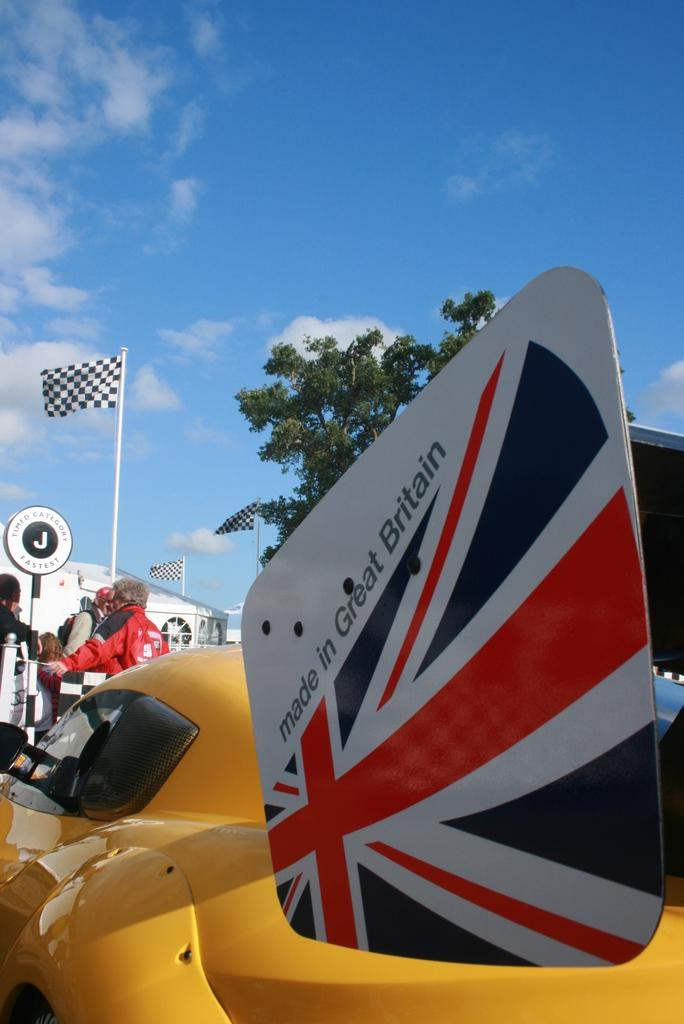<image>
Write a terse but informative summary of the picture. A yellow race car with a sign on it that says made in Great Britian. 